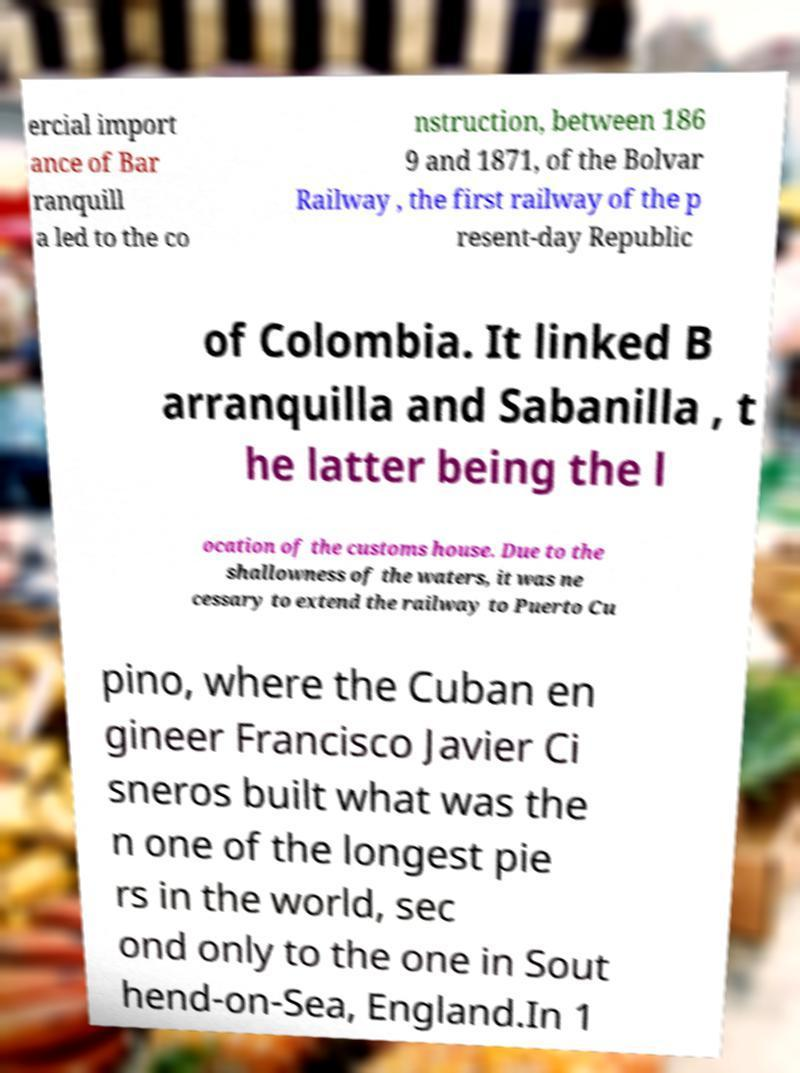Please read and relay the text visible in this image. What does it say? ercial import ance of Bar ranquill a led to the co nstruction, between 186 9 and 1871, of the Bolvar Railway , the first railway of the p resent-day Republic of Colombia. It linked B arranquilla and Sabanilla , t he latter being the l ocation of the customs house. Due to the shallowness of the waters, it was ne cessary to extend the railway to Puerto Cu pino, where the Cuban en gineer Francisco Javier Ci sneros built what was the n one of the longest pie rs in the world, sec ond only to the one in Sout hend-on-Sea, England.In 1 